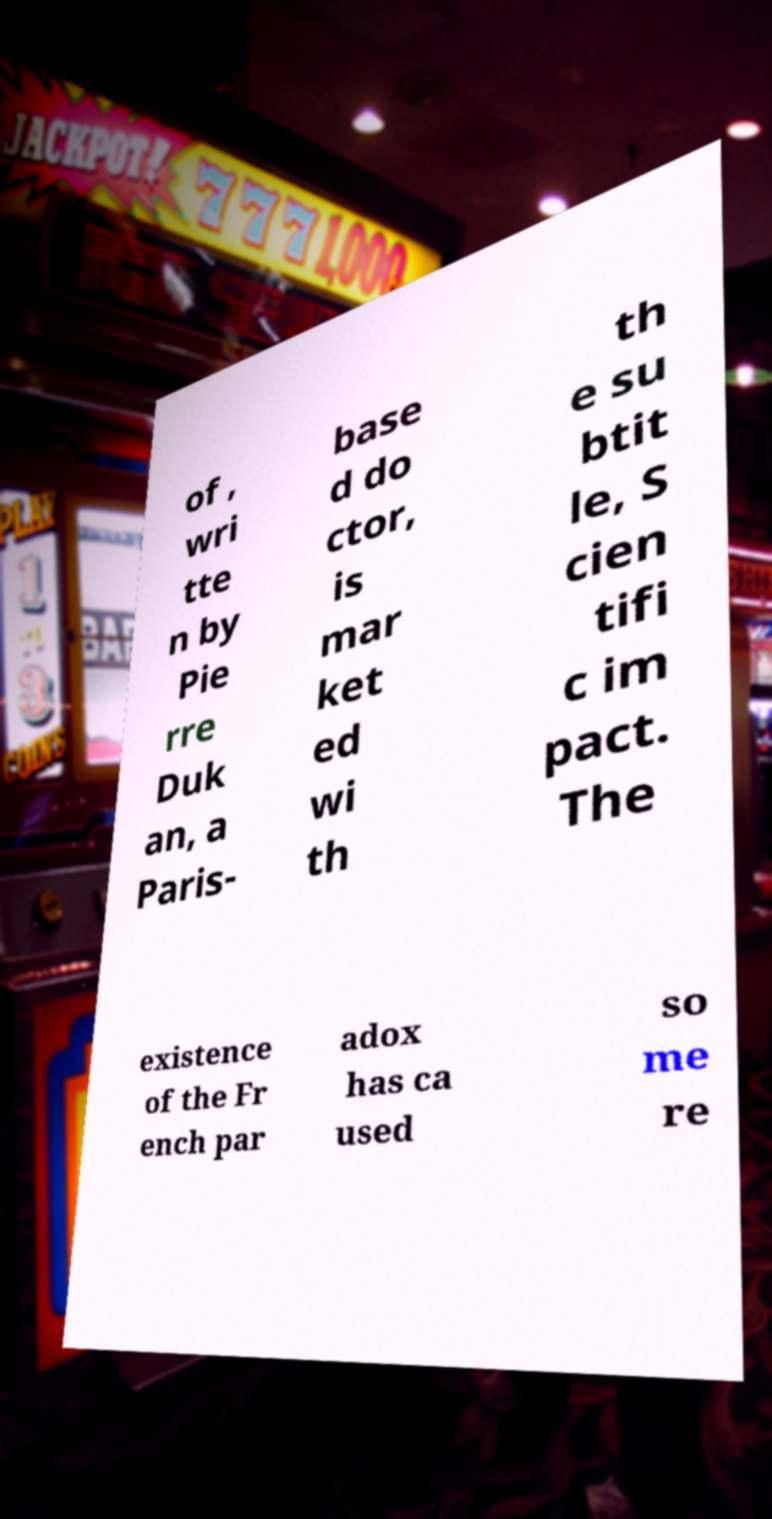Can you accurately transcribe the text from the provided image for me? of , wri tte n by Pie rre Duk an, a Paris- base d do ctor, is mar ket ed wi th th e su btit le, S cien tifi c im pact. The existence of the Fr ench par adox has ca used so me re 